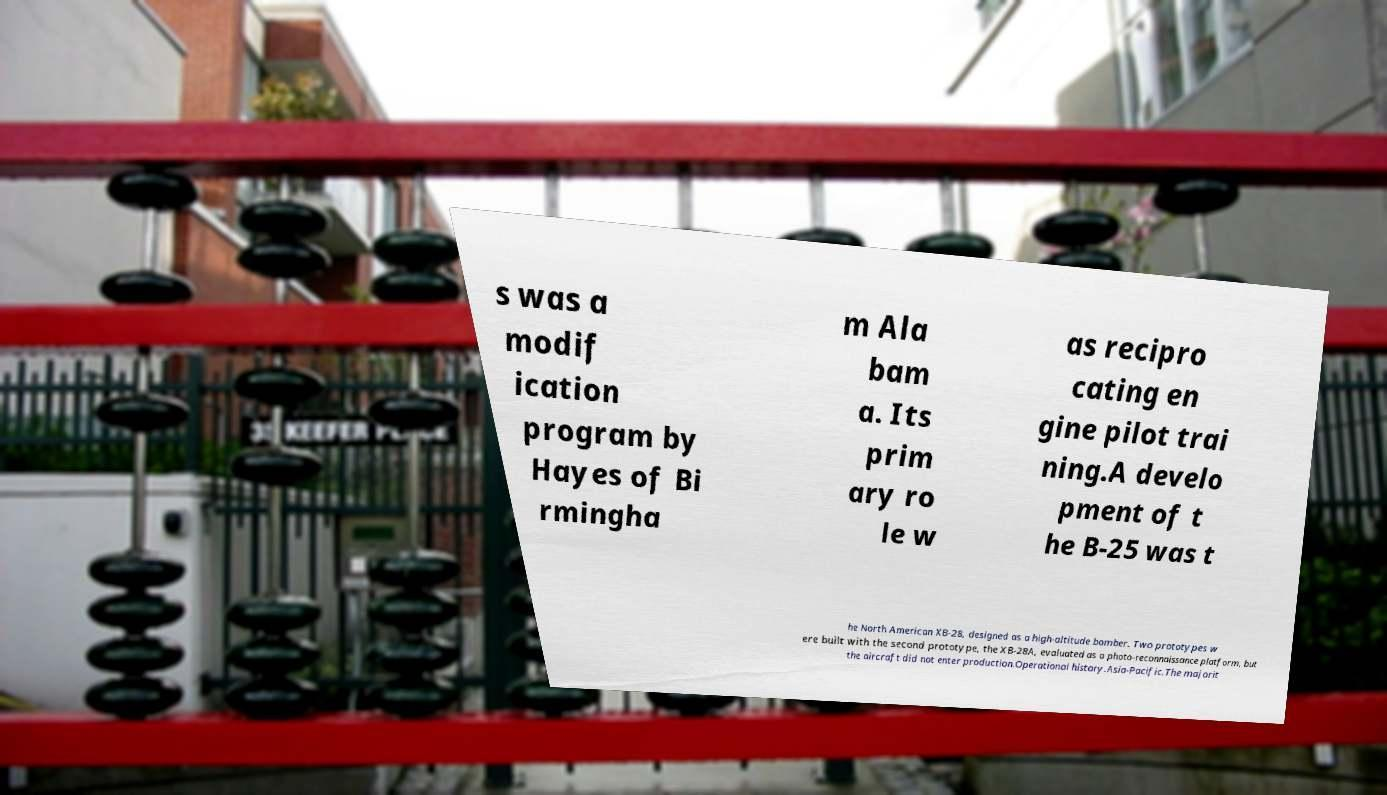Could you assist in decoding the text presented in this image and type it out clearly? s was a modif ication program by Hayes of Bi rmingha m Ala bam a. Its prim ary ro le w as recipro cating en gine pilot trai ning.A develo pment of t he B-25 was t he North American XB-28, designed as a high-altitude bomber. Two prototypes w ere built with the second prototype, the XB-28A, evaluated as a photo-reconnaissance platform, but the aircraft did not enter production.Operational history.Asia-Pacific.The majorit 